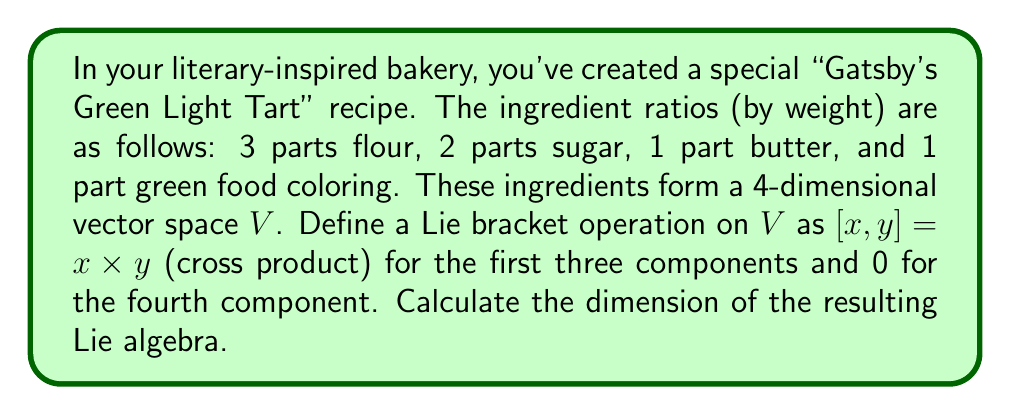Show me your answer to this math problem. To solve this problem, we need to follow these steps:

1) First, we need to understand what defines a Lie algebra. A Lie algebra is a vector space $V$ over a field $F$ with a bilinear operation $[,]: V \times V \rightarrow V$ called the Lie bracket, which satisfies:

   a) Anticommutativity: $[x,y] = -[y,x]$ for all $x,y \in V$
   b) Jacobi identity: $[x,[y,z]] + [y,[z,x]] + [z,[x,y]] = 0$ for all $x,y,z \in V$

2) In our case, the vector space $V$ is 4-dimensional, representing the four ingredients. Let's denote a general vector as $(a,b,c,d)$ where $a,b,c,d$ represent the amounts of flour, sugar, butter, and food coloring respectively.

3) The Lie bracket is defined as the cross product for the first three components and 0 for the fourth. For two vectors $x=(x_1,x_2,x_3,x_4)$ and $y=(y_1,y_2,y_3,y_4)$:

   $[x,y] = (x_2y_3-x_3y_2, x_3y_1-x_1y_3, x_1y_2-x_2y_1, 0)$

4) This operation satisfies anticommutativity and the Jacobi identity, so it indeed defines a Lie algebra.

5) To find the dimension of this Lie algebra, we need to find a basis for the space of all possible results of the Lie bracket operation.

6) From the definition of the bracket, we can see that all results will have the form $(a,b,c,0)$ where $a,b,c$ are arbitrary real numbers. This means that the image of the Lie bracket operation is a 3-dimensional subspace of $V$.

7) Therefore, the dimension of the Lie algebra is 3.
Answer: The dimension of the resulting Lie algebra is 3. 